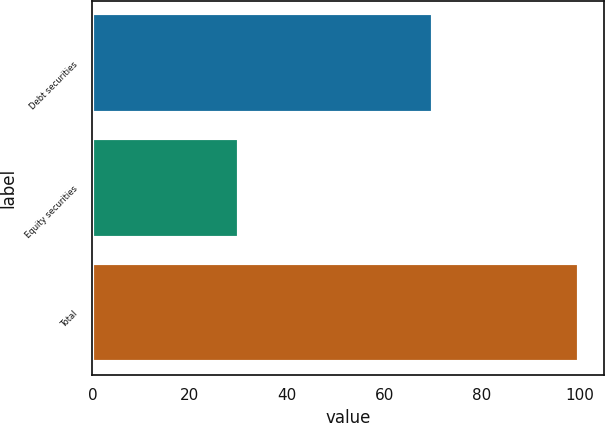Convert chart to OTSL. <chart><loc_0><loc_0><loc_500><loc_500><bar_chart><fcel>Debt securities<fcel>Equity securities<fcel>Total<nl><fcel>70<fcel>30<fcel>100<nl></chart> 